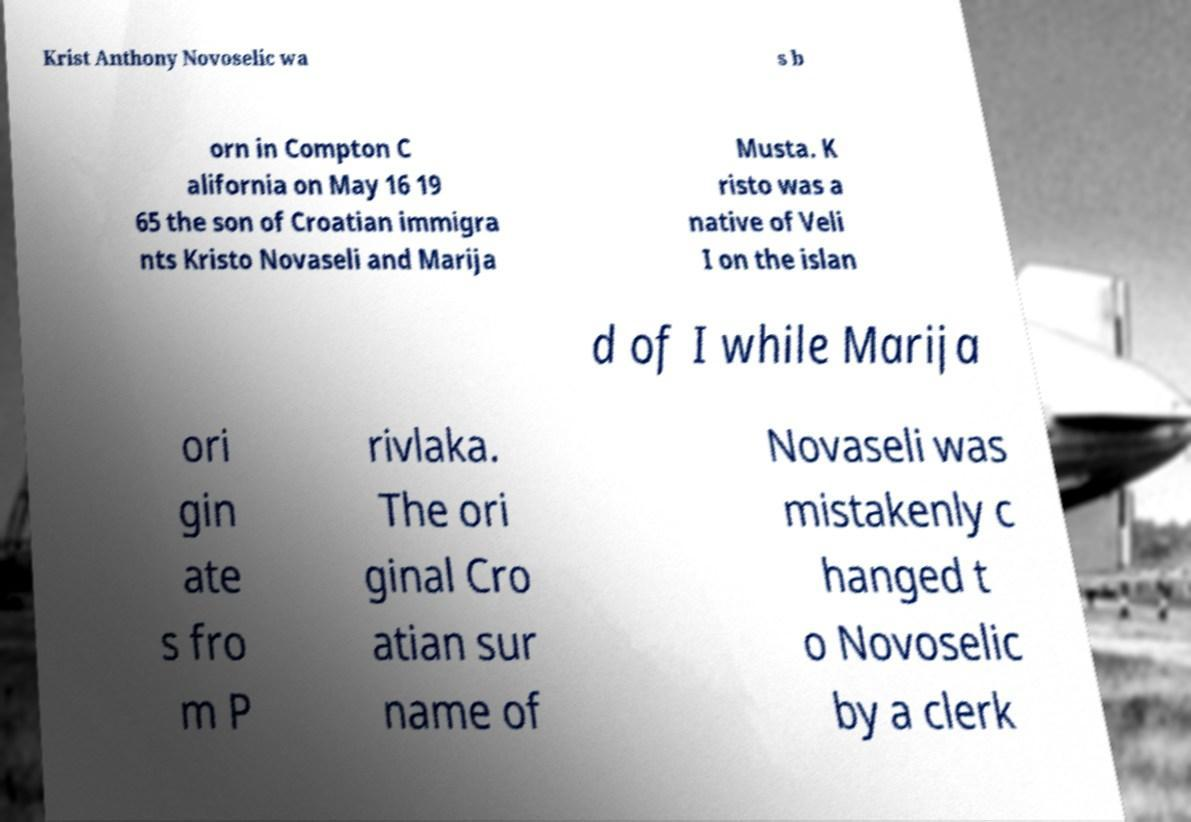Could you extract and type out the text from this image? Krist Anthony Novoselic wa s b orn in Compton C alifornia on May 16 19 65 the son of Croatian immigra nts Kristo Novaseli and Marija Musta. K risto was a native of Veli I on the islan d of I while Marija ori gin ate s fro m P rivlaka. The ori ginal Cro atian sur name of Novaseli was mistakenly c hanged t o Novoselic by a clerk 